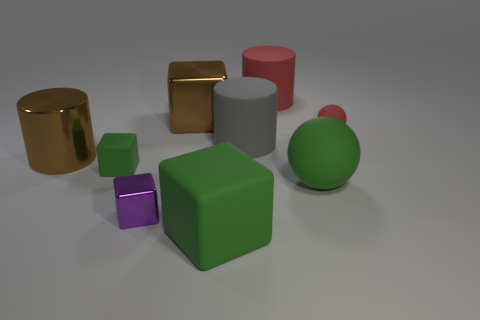Are there any big green objects that have the same material as the tiny purple block?
Ensure brevity in your answer.  No. There is a purple object; what shape is it?
Your answer should be compact. Cube. What number of small purple metal cubes are there?
Your response must be concise. 1. What color is the cylinder that is to the left of the matte cube that is in front of the small purple metal thing?
Offer a terse response. Brown. What color is the rubber object that is the same size as the red matte sphere?
Your answer should be compact. Green. Is there another cube of the same color as the tiny metallic block?
Give a very brief answer. No. Are any brown objects visible?
Give a very brief answer. Yes. What shape is the big green object that is right of the gray rubber cylinder?
Provide a succinct answer. Sphere. What number of rubber objects are in front of the big red matte cylinder and on the left side of the small red matte thing?
Provide a succinct answer. 4. How many other objects are there of the same size as the red cylinder?
Make the answer very short. 5. 